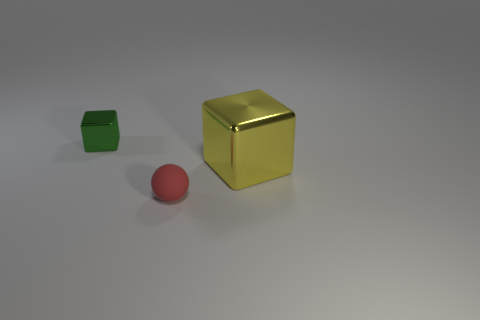Does the ball have the same material as the cube that is to the left of the large cube?
Your answer should be compact. No. How many objects are either red metal cubes or tiny matte spheres?
Your response must be concise. 1. There is a cube left of the big metallic thing; is it the same size as the metallic thing in front of the tiny metal thing?
Provide a short and direct response. No. How many cubes are either tiny blue shiny objects or yellow metallic things?
Keep it short and to the point. 1. Is there a small rubber ball?
Give a very brief answer. Yes. Is there anything else that is the same shape as the matte thing?
Provide a short and direct response. No. What number of objects are metal objects left of the tiny matte thing or metallic blocks?
Keep it short and to the point. 2. How many tiny red objects are to the right of the tiny thing on the left side of the tiny thing in front of the tiny metallic thing?
Provide a short and direct response. 1. Is there anything else that is the same size as the yellow metal object?
Your answer should be compact. No. There is a thing in front of the shiny cube to the right of the tiny thing behind the small matte ball; what shape is it?
Offer a very short reply. Sphere. 